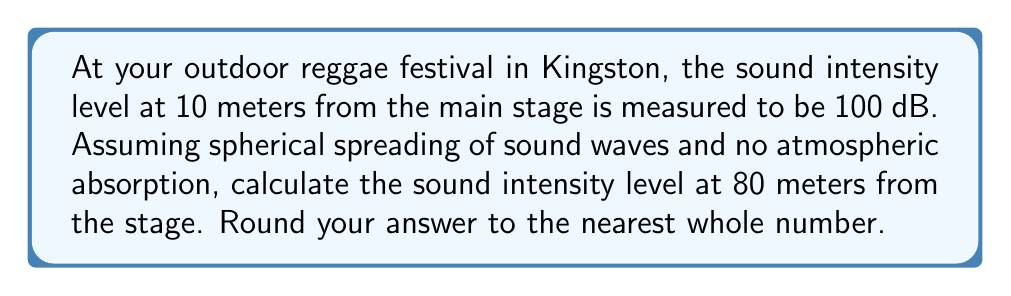Solve this math problem. To solve this problem, we'll use the inverse square law for sound intensity and the decibel scale. Let's break it down step-by-step:

1) The inverse square law states that sound intensity is inversely proportional to the square of the distance from the source:

   $$I \propto \frac{1}{r^2}$$

2) We can write this as a ratio:

   $$\frac{I_1}{I_2} = \frac{r_2^2}{r_1^2}$$

3) The decibel scale for sound intensity level (SIL) is defined as:

   $$SIL = 10 \log_{10}\left(\frac{I}{I_0}\right)$$

   where $I_0$ is the reference intensity.

4) The difference in SIL between two points is:

   $$SIL_2 - SIL_1 = 10 \log_{10}\left(\frac{I_2}{I_1}\right)$$

5) Substituting the inverse square law ratio:

   $$SIL_2 - SIL_1 = 10 \log_{10}\left(\frac{r_1^2}{r_2^2}\right)$$

6) Now, let's plug in our values:
   $r_1 = 10$ m, $r_2 = 80$ m, $SIL_1 = 100$ dB

   $$SIL_2 - 100 = 10 \log_{10}\left(\frac{10^2}{80^2}\right)$$

7) Simplify:

   $$SIL_2 - 100 = 10 \log_{10}\left(\frac{100}{6400}\right) = 10 \log_{10}(0.015625)$$

8) Calculate:

   $$SIL_2 - 100 = 10 \cdot (-1.8062) = -18.062$$

9) Solve for $SIL_2$:

   $$SIL_2 = 100 - 18.062 = 81.938$$

10) Rounding to the nearest whole number:

    $$SIL_2 \approx 82 \text{ dB}$$
Answer: 82 dB 